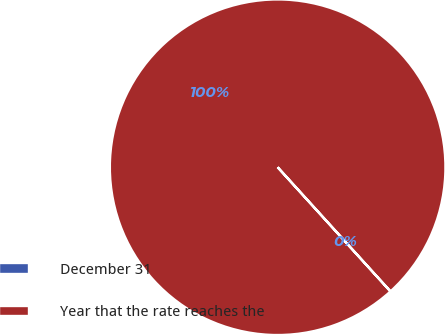<chart> <loc_0><loc_0><loc_500><loc_500><pie_chart><fcel>December 31<fcel>Year that the rate reaches the<nl><fcel>0.01%<fcel>99.99%<nl></chart> 